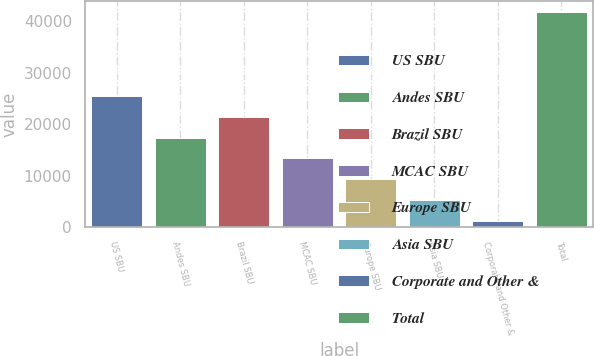Convert chart. <chart><loc_0><loc_0><loc_500><loc_500><bar_chart><fcel>US SBU<fcel>Andes SBU<fcel>Brazil SBU<fcel>MCAC SBU<fcel>Europe SBU<fcel>Asia SBU<fcel>Corporate and Other &<fcel>Total<nl><fcel>25573.2<fcel>17444.8<fcel>21509<fcel>13380.6<fcel>9316.4<fcel>5252.2<fcel>1188<fcel>41830<nl></chart> 